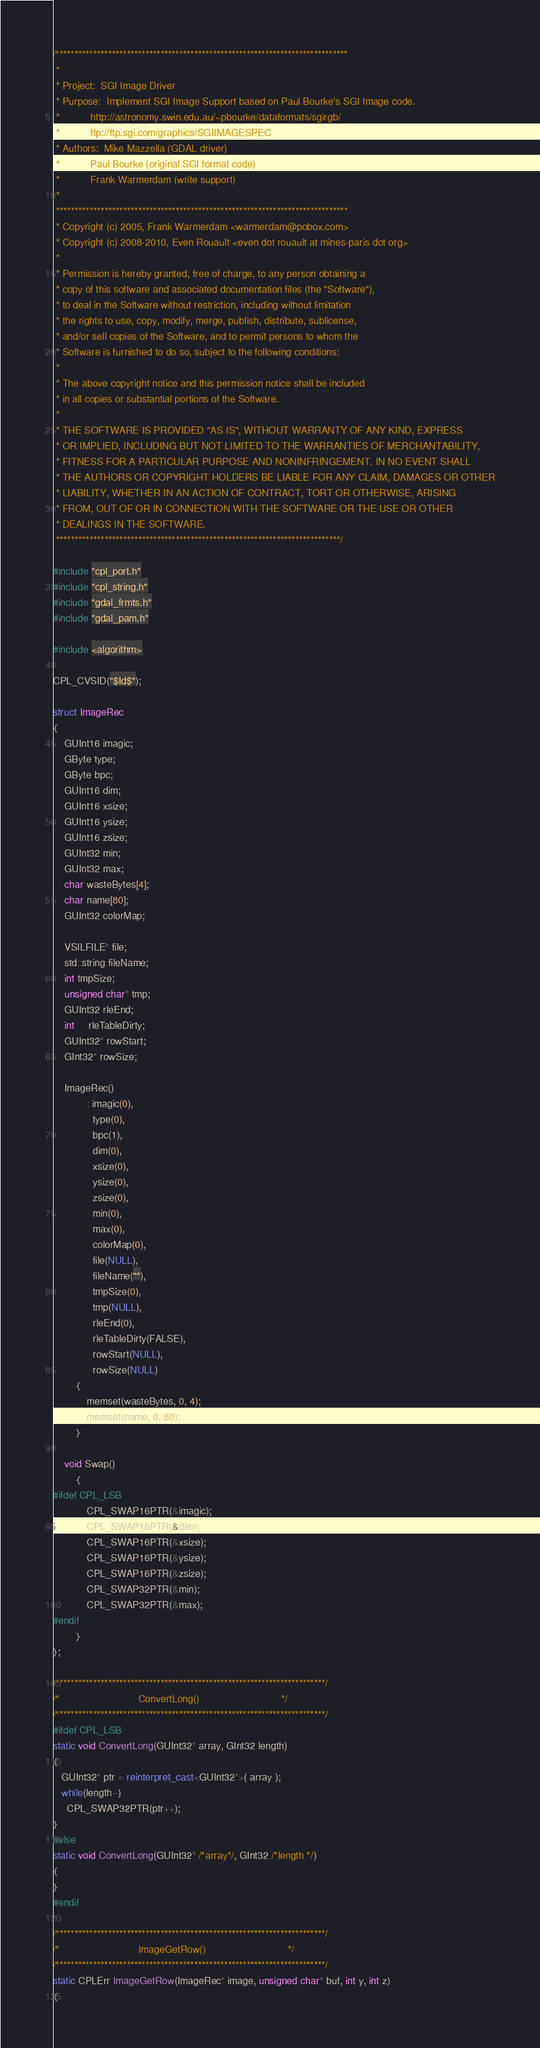Convert code to text. <code><loc_0><loc_0><loc_500><loc_500><_C++_>/******************************************************************************
 *
 * Project:  SGI Image Driver
 * Purpose:  Implement SGI Image Support based on Paul Bourke's SGI Image code.
 *           http://astronomy.swin.edu.au/~pbourke/dataformats/sgirgb/
 *           ftp://ftp.sgi.com/graphics/SGIIMAGESPEC
 * Authors:  Mike Mazzella (GDAL driver)
 *           Paul Bourke (original SGI format code)
 *           Frank Warmerdam (write support)
 *
 ******************************************************************************
 * Copyright (c) 2005, Frank Warmerdam <warmerdam@pobox.com>
 * Copyright (c) 2008-2010, Even Rouault <even dot rouault at mines-paris dot org>
 *
 * Permission is hereby granted, free of charge, to any person obtaining a
 * copy of this software and associated documentation files (the "Software"),
 * to deal in the Software without restriction, including without limitation
 * the rights to use, copy, modify, merge, publish, distribute, sublicense,
 * and/or sell copies of the Software, and to permit persons to whom the
 * Software is furnished to do so, subject to the following conditions:
 *
 * The above copyright notice and this permission notice shall be included
 * in all copies or substantial portions of the Software.
 *
 * THE SOFTWARE IS PROVIDED "AS IS", WITHOUT WARRANTY OF ANY KIND, EXPRESS
 * OR IMPLIED, INCLUDING BUT NOT LIMITED TO THE WARRANTIES OF MERCHANTABILITY,
 * FITNESS FOR A PARTICULAR PURPOSE AND NONINFRINGEMENT. IN NO EVENT SHALL
 * THE AUTHORS OR COPYRIGHT HOLDERS BE LIABLE FOR ANY CLAIM, DAMAGES OR OTHER
 * LIABILITY, WHETHER IN AN ACTION OF CONTRACT, TORT OR OTHERWISE, ARISING
 * FROM, OUT OF OR IN CONNECTION WITH THE SOFTWARE OR THE USE OR OTHER
 * DEALINGS IN THE SOFTWARE.
 ****************************************************************************/

#include "cpl_port.h"
#include "cpl_string.h"
#include "gdal_frmts.h"
#include "gdal_pam.h"

#include <algorithm>

CPL_CVSID("$Id$");

struct ImageRec
{
    GUInt16 imagic;
    GByte type;
    GByte bpc;
    GUInt16 dim;
    GUInt16 xsize;
    GUInt16 ysize;
    GUInt16 zsize;
    GUInt32 min;
    GUInt32 max;
    char wasteBytes[4];
    char name[80];
    GUInt32 colorMap;

    VSILFILE* file;
    std::string fileName;
    int tmpSize;
    unsigned char* tmp;
    GUInt32 rleEnd;
    int     rleTableDirty;
    GUInt32* rowStart;
    GInt32* rowSize;

    ImageRec()
            : imagic(0),
              type(0),
              bpc(1),
              dim(0),
              xsize(0),
              ysize(0),
              zsize(0),
              min(0),
              max(0),
              colorMap(0),
              file(NULL),
              fileName(""),
              tmpSize(0),
              tmp(NULL),
              rleEnd(0),
              rleTableDirty(FALSE),
              rowStart(NULL),
              rowSize(NULL)
        {
            memset(wasteBytes, 0, 4);
            memset(name, 0, 80);
        }

    void Swap()
        {
#ifdef CPL_LSB
            CPL_SWAP16PTR(&imagic);
            CPL_SWAP16PTR(&dim);
            CPL_SWAP16PTR(&xsize);
            CPL_SWAP16PTR(&ysize);
            CPL_SWAP16PTR(&zsize);
            CPL_SWAP32PTR(&min);
            CPL_SWAP32PTR(&max);
#endif
        }
};

/************************************************************************/
/*                            ConvertLong()                             */
/************************************************************************/
#ifdef CPL_LSB
static void ConvertLong(GUInt32* array, GInt32 length)
{
   GUInt32* ptr = reinterpret_cast<GUInt32*>( array );
   while(length--)
     CPL_SWAP32PTR(ptr++);
}
#else
static void ConvertLong(GUInt32* /*array*/, GInt32 /*length */)
{
}
#endif

/************************************************************************/
/*                            ImageGetRow()                             */
/************************************************************************/
static CPLErr ImageGetRow(ImageRec* image, unsigned char* buf, int y, int z)
{</code> 